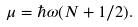Convert formula to latex. <formula><loc_0><loc_0><loc_500><loc_500>\mu = \hbar { \omega } ( N + 1 / 2 ) .</formula> 